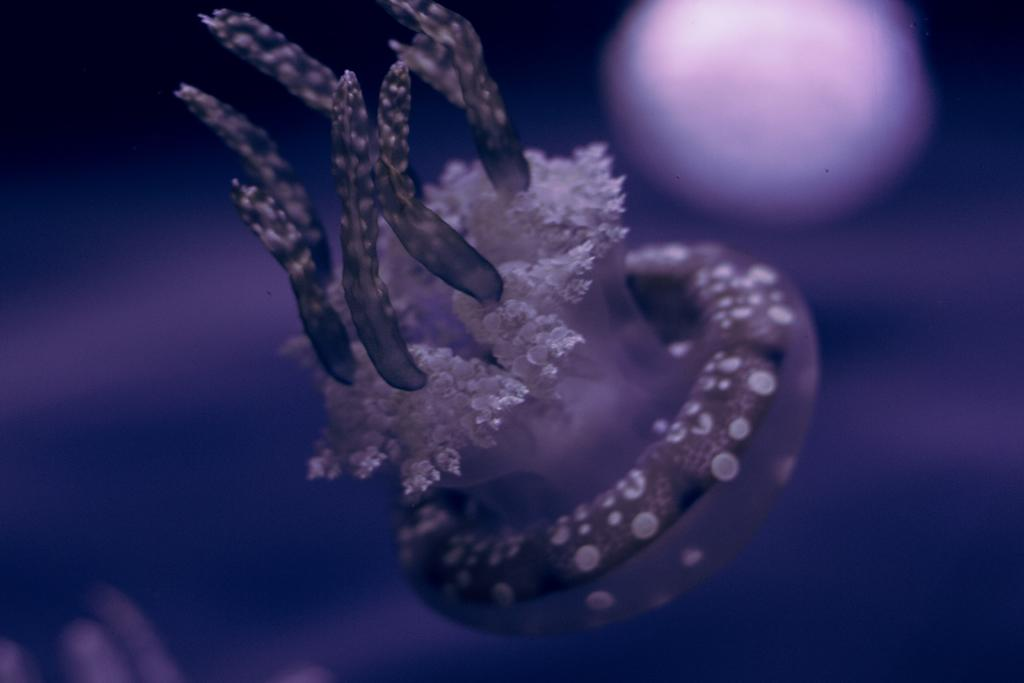What is the main subject of the image? There is an object in the image. What color is the background of the image? The background of the image is violet in color. What language is being spoken by the body in the image? There is no body or language spoken in the image, as the facts only mention an object and a violet background. 